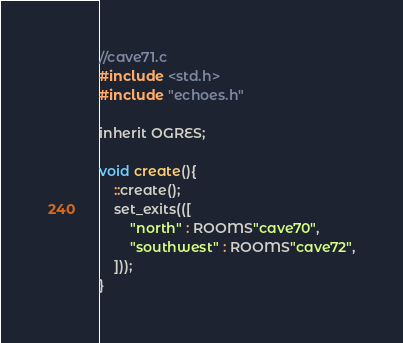<code> <loc_0><loc_0><loc_500><loc_500><_C_>//cave71.c
#include <std.h>
#include "echoes.h"

inherit OGRES;

void create(){
    ::create();
    set_exits(([
        "north" : ROOMS"cave70",
        "southwest" : ROOMS"cave72",
   	]));
}
</code> 